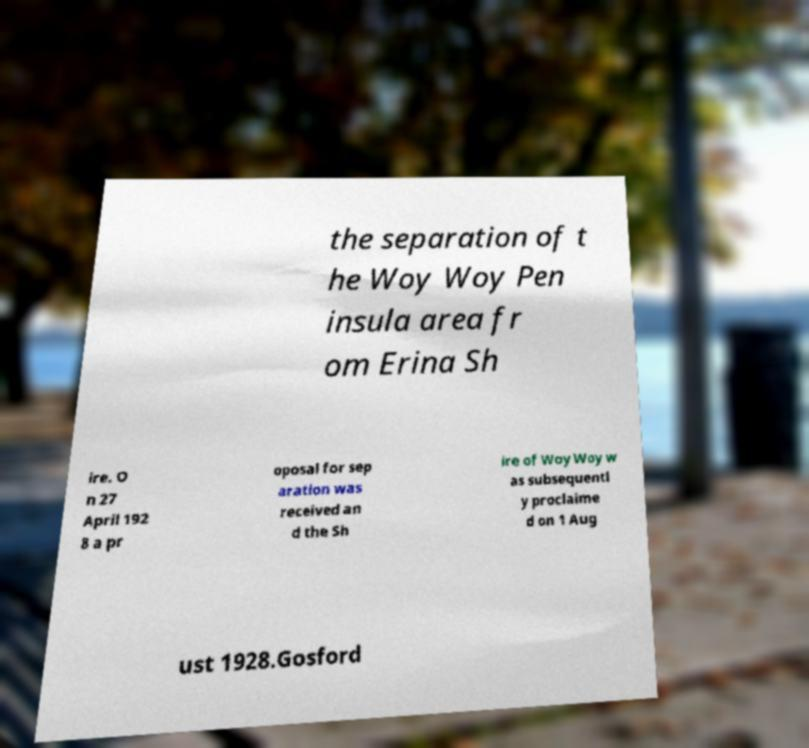Could you assist in decoding the text presented in this image and type it out clearly? the separation of t he Woy Woy Pen insula area fr om Erina Sh ire. O n 27 April 192 8 a pr oposal for sep aration was received an d the Sh ire of Woy Woy w as subsequentl y proclaime d on 1 Aug ust 1928.Gosford 